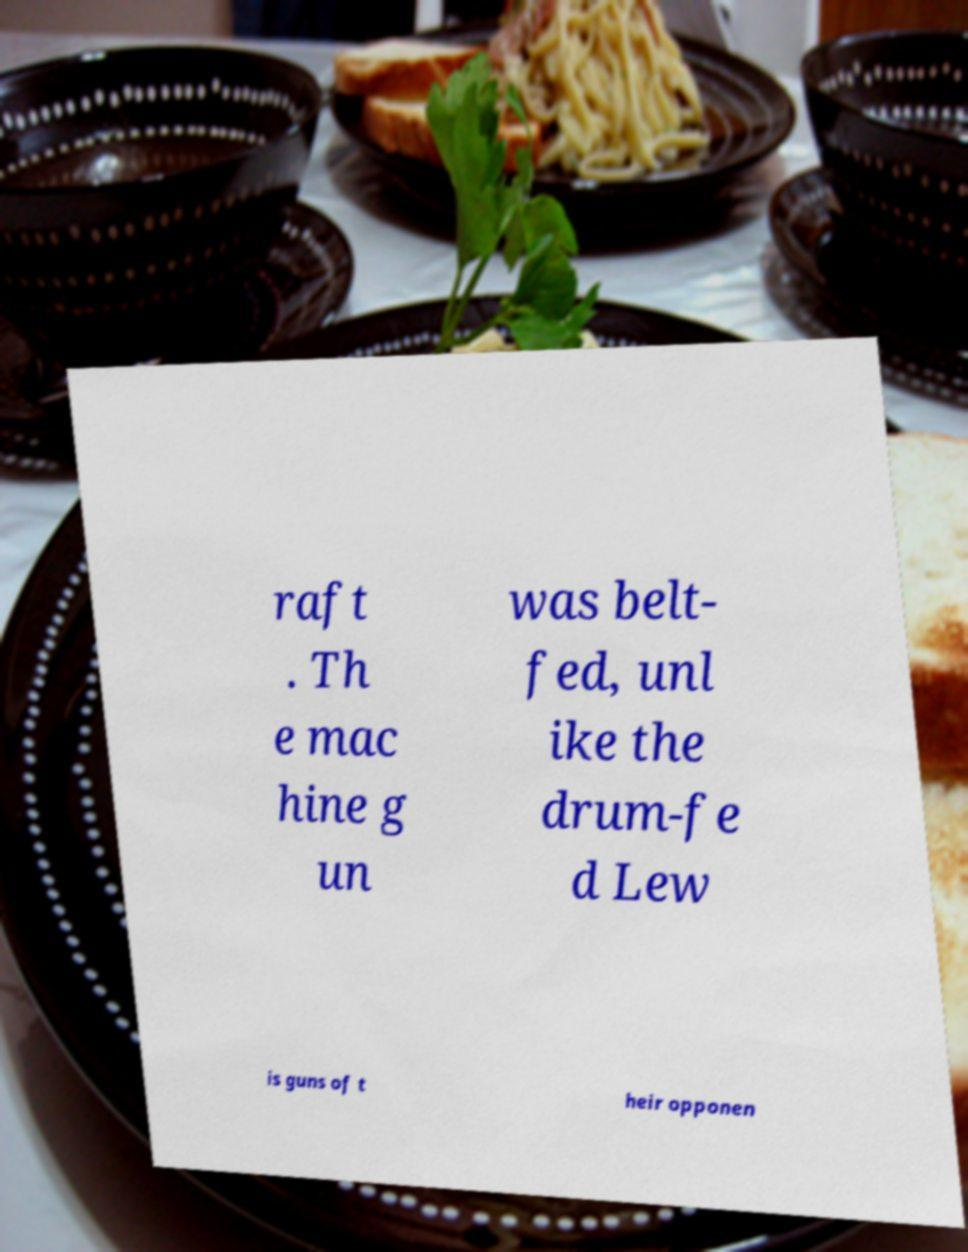There's text embedded in this image that I need extracted. Can you transcribe it verbatim? raft . Th e mac hine g un was belt- fed, unl ike the drum-fe d Lew is guns of t heir opponen 